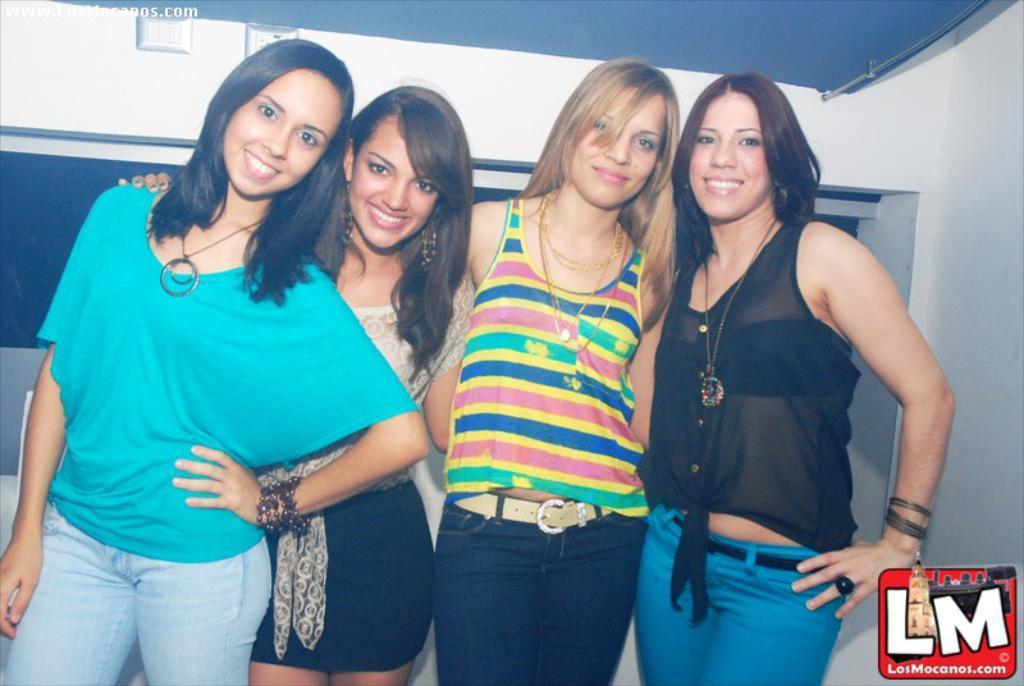Can you describe this image briefly? In this picture we can see four women standing, in the background there is a wall, at the right bottom we can see a logo. 